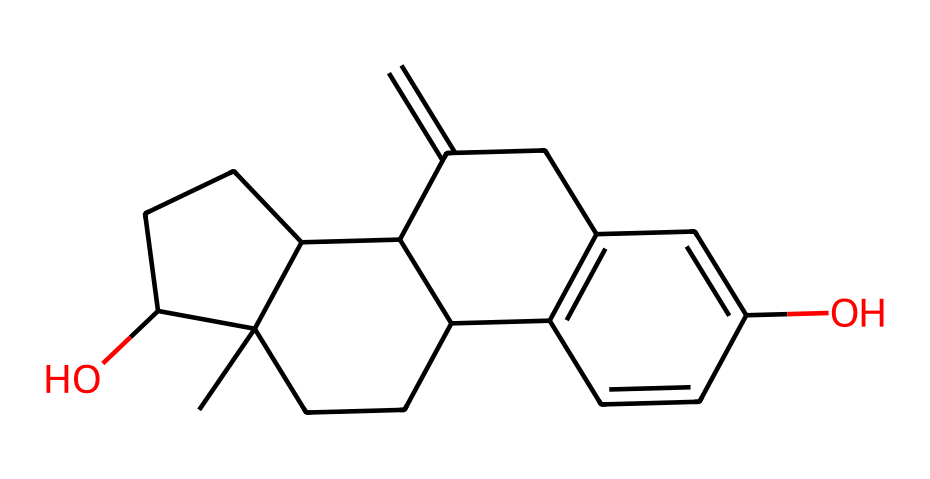What is the molecular formula of estrogen based on its structure? To derive the molecular formula from the provided SMILES, count the different atoms represented in the structure. By interpreting the SMILES, we can identify 18 carbon (C) atoms, 22 hydrogen (H) atoms, and 2 oxygen (O) atoms. Therefore, the molecular formula is C18H22O2.
Answer: C18H22O2 How many hydroxy (–OH) groups are present in the structure of estrogen? By examining the structure and identifying functional groups, there are two –OH groups located on the rings portion of the chemical structure. These groups indicate the presence of hydroxy groups.
Answer: 2 What type of chemical compound is estrogen categorized as? Estrogen is characterized as a steroid due to its multi-ring structure, typical of steroid hormones. The presence of these fused rings is a key feature of steroids.
Answer: steroid What is the total number of rings present in the structure of estrogen? The structure reveals a fused multi-ring composition. Counting the visualized rings in the SMILES, there are four rings present.
Answer: 4 What functional groups are present in the estrogen structure? The chemical structure includes hydroxy (–OH) groups as functional groups. They contribute to the polarity of the molecule, and steroid hormones like estrogen generally possess these polar groups.
Answer: hydroxy groups Which part of the structure indicates that estrogen is a hydrophobic molecule? The extensive hydrocarbon (C-H) framework, represented by the large number of carbon and hydrogen atoms, suggests hydrophobic properties, characteristic of steroid hormones. The absence of electronegative atoms in the backbone supports this.
Answer: hydrocarbon framework What is the significance of the double bonds in the estrogen structure? The presence of double bonds in the steroid structure contributes to the overall stability and conformational flexibility of estrogen. These unsaturations can affect the molecule's reactivity and how estrogen interacts with its receptors.
Answer: stability and reactivity 